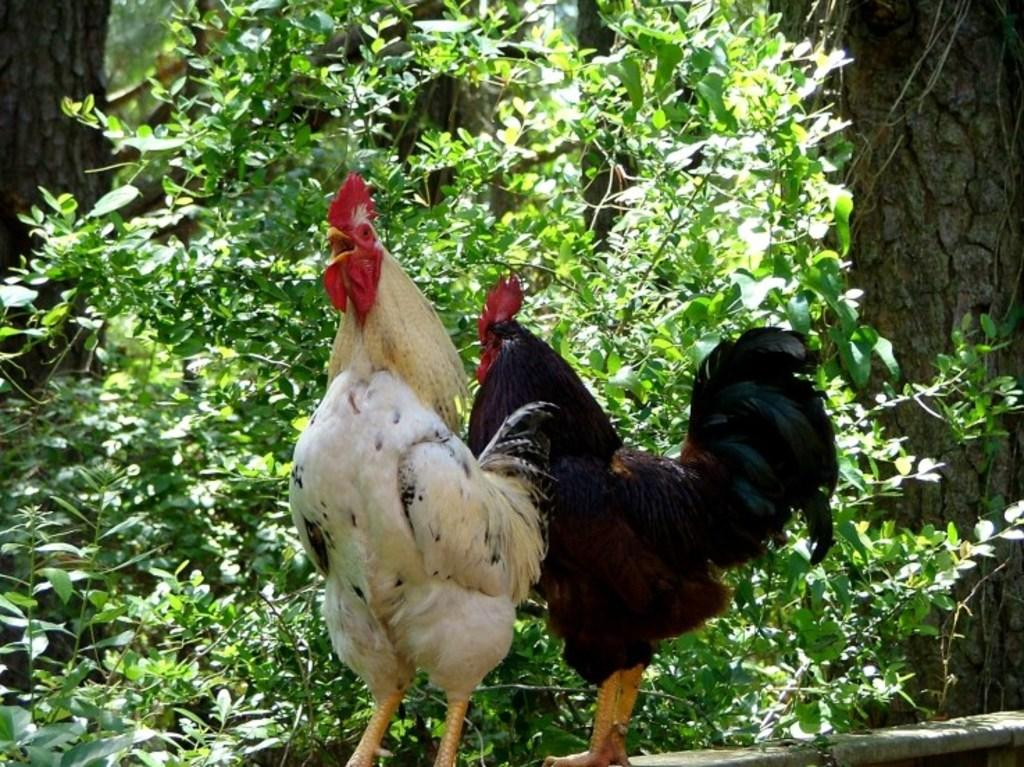How many roosters are present in the image? There are two roosters in the image. What are the roosters doing in the image? The roosters are standing in the image. What can be seen in the background of the image? There are trees in the background of the image. What type of silk fabric is draped over the roosters in the image? There is no silk fabric present in the image; the roosters are standing without any fabric draped over them. 